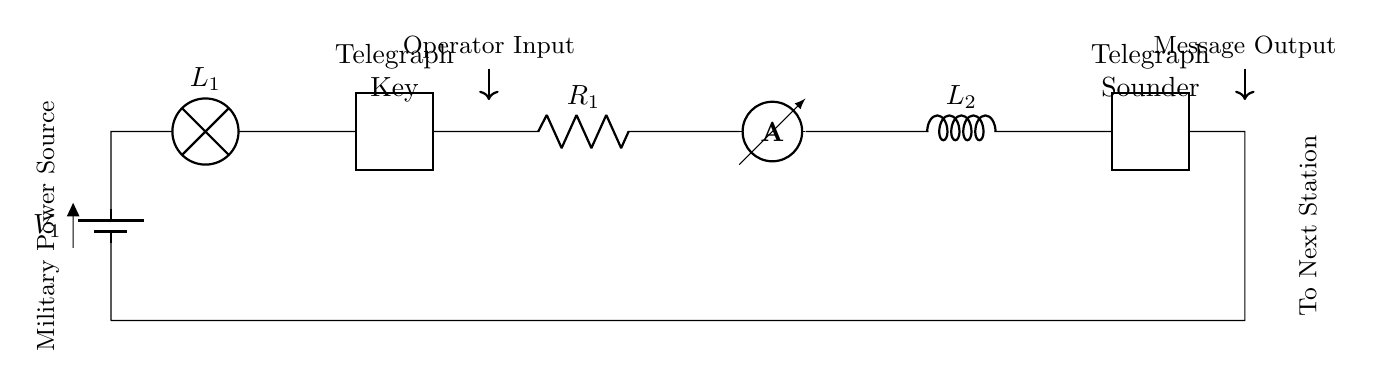What is the voltage source in this circuit? The voltage source is represented by the battery labeled V1 at the beginning of the circuit. It provides the necessary potential difference for the operation of the components in series.
Answer: V1 What is the function of the component labeled as 'Telegraph Key'? The 'Telegraph Key' acts as a switch in the circuit, allowing the operator to control the flow of current, and thus, manage the signaling process in the telegraph system.
Answer: Switch How many components are in series with the power source? By counting the components connected one after another starting from the voltage source to the end, we find that there are six components including the battery.
Answer: 6 Which component provides the audible output in the circuit? The 'Telegraph Sounder' is responsible for converting electrical signals into audible sounds, signaling the operator at the next station.
Answer: Telegraph Sounder What is the purpose of the inductor labeled L2? The inductor L2 is used to store magnetic energy in the circuit and can help filter out electrical noise, ensuring a clearer signal transmission during communication.
Answer: Energy storage How does the 'Telegraph Key' affect the current flow? When the 'Telegraph Key' is closed (pressed), it completes the circuit, allowing current to flow through all subsequent components. When opened (released), current flow is interrupted, stopping the signaling.
Answer: Interrupts current flow 